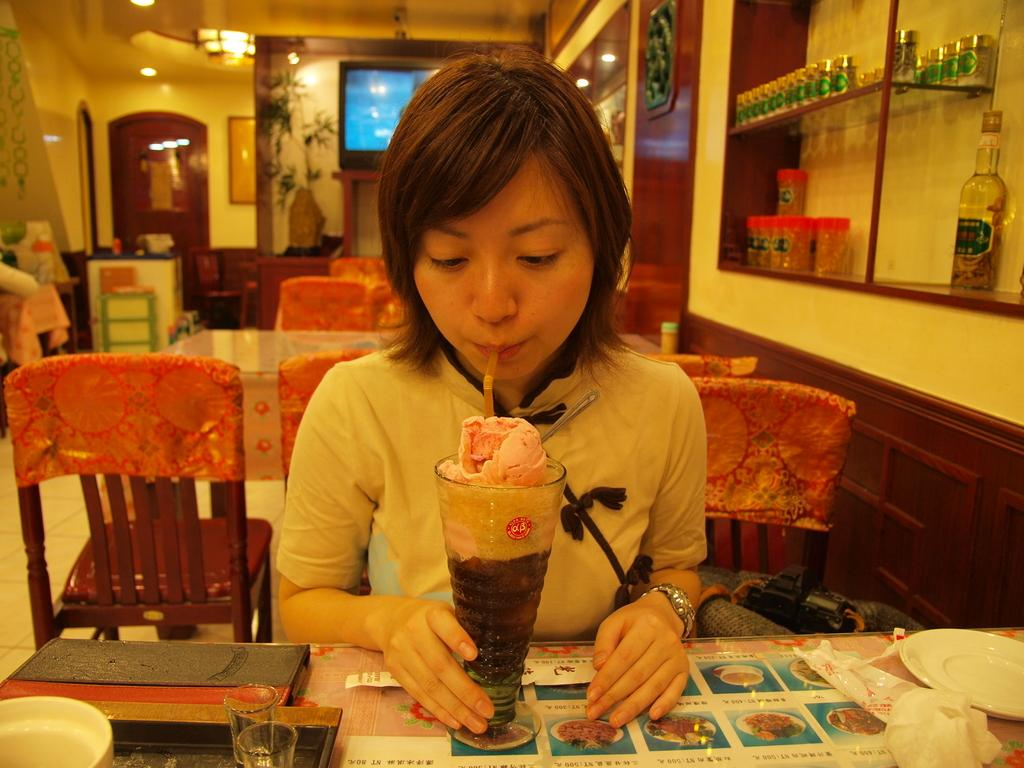What is the woman in the image doing? The woman is sitting in a chair and drinking a shake. Where is the shake located in the image? The shake is placed on a table in front of her. What type of furniture can be seen in the image? There are tables and chairs in the image. What is located behind the woman? There is a television behind the woman. What type of seed is the woman planting in the image? There is no seed or planting activity present in the image. What type of toothbrush is the woman using in the image? There is no toothbrush present in the image. 